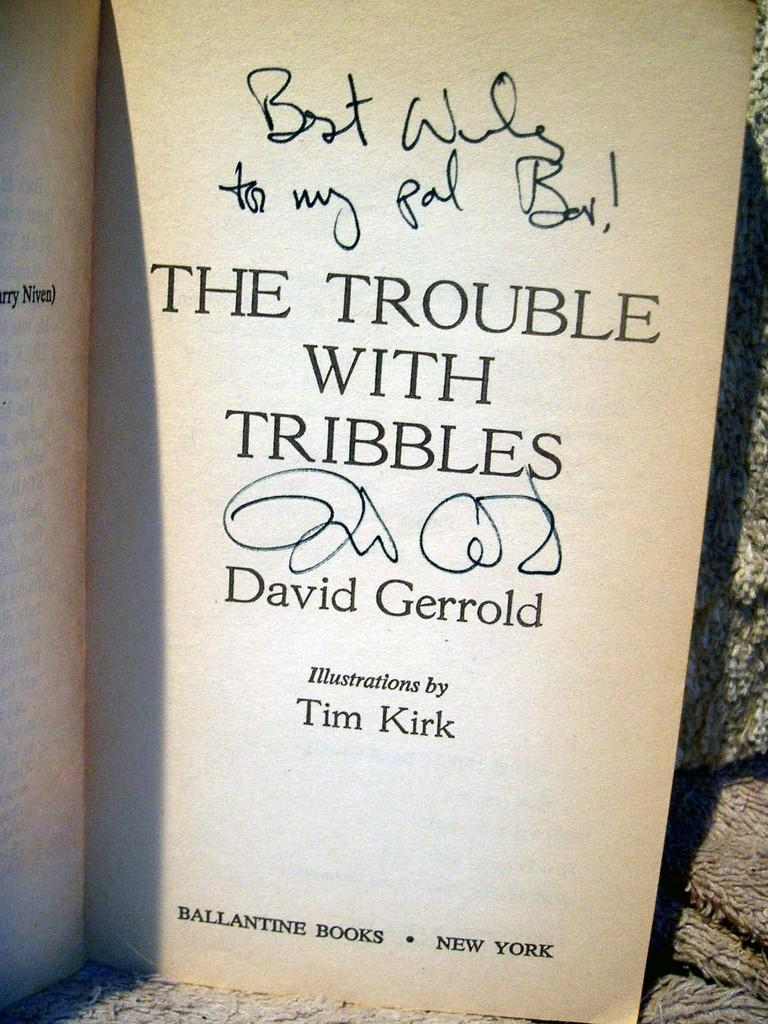<image>
Render a clear and concise summary of the photo. A autographed sign copy of  The Trouble with Tribbles book. 